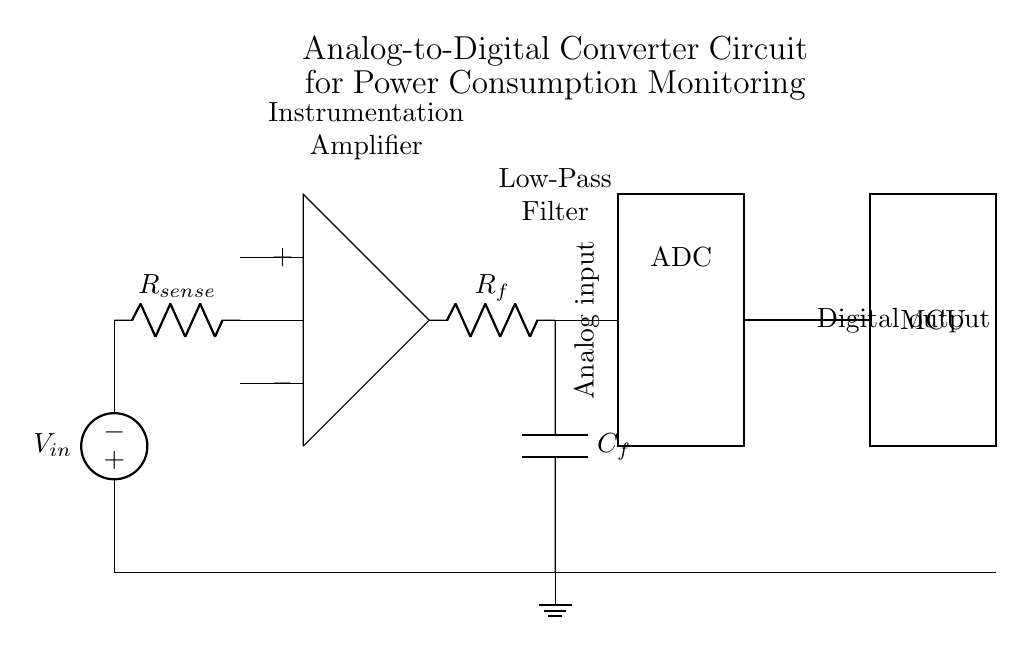What is the type of ADC used in this circuit? The diagram shows a rectangle labeled "ADC," which indicates that it is an Analog-to-Digital Converter. This component converts the analog voltage signal to a digital signal for further processing.
Answer: ADC What is the function of the current sensor represented in the circuit? The current sensor is represented by the resistor labeled "R_sense." Its function is to sense the current flowing through the circuit by measuring the voltage drop across it, which is related to the current value.
Answer: Sensing current What do the "+" and "-" symbols indicate at the instrumentation amplifier? The "+" and "-" symbols at the instrumentation amplifier indicate the positive and negative input terminals of the amplifier, respectively. This configuration is necessary for differential amplification of the input signals.
Answer: Positive and negative inputs What component is used for filtering in this circuit? The component used for filtering in this circuit is the low-pass filter, represented by the combination of a resistor labeled "R_f" and a capacitor labeled "C_f." It smooths the output signal by allowing low-frequency signals to pass while attenuating high-frequency noise.
Answer: Low-pass filter How does the microcontroller interface with the ADC in this design? The microcontroller (MCU) interfaces with the ADC through the wire connected to the digital output of the ADC. Therefore, the digital signal processed by the ADC is sent directly to the microcontroller for further processing or control actions.
Answer: Digital output connection What is the purpose of the low-pass filter in this circuit? The low-pass filter smooths the output signal from the instrumentation amplifier before it reaches the ADC. It removes high-frequency noise that could distort the analog signal, ensuring that the ADC receives a clean, accurate representation of the analog input.
Answer: Noise reduction What is the overall purpose of the circuit diagram? The overall purpose of the circuit diagram is to provide an analog-to-digital converter circuit that monitors power consumption in electronics. It transforms the analog signal associated with power consumption into a digital signal for analysis and control purposes.
Answer: Monitoring power consumption 